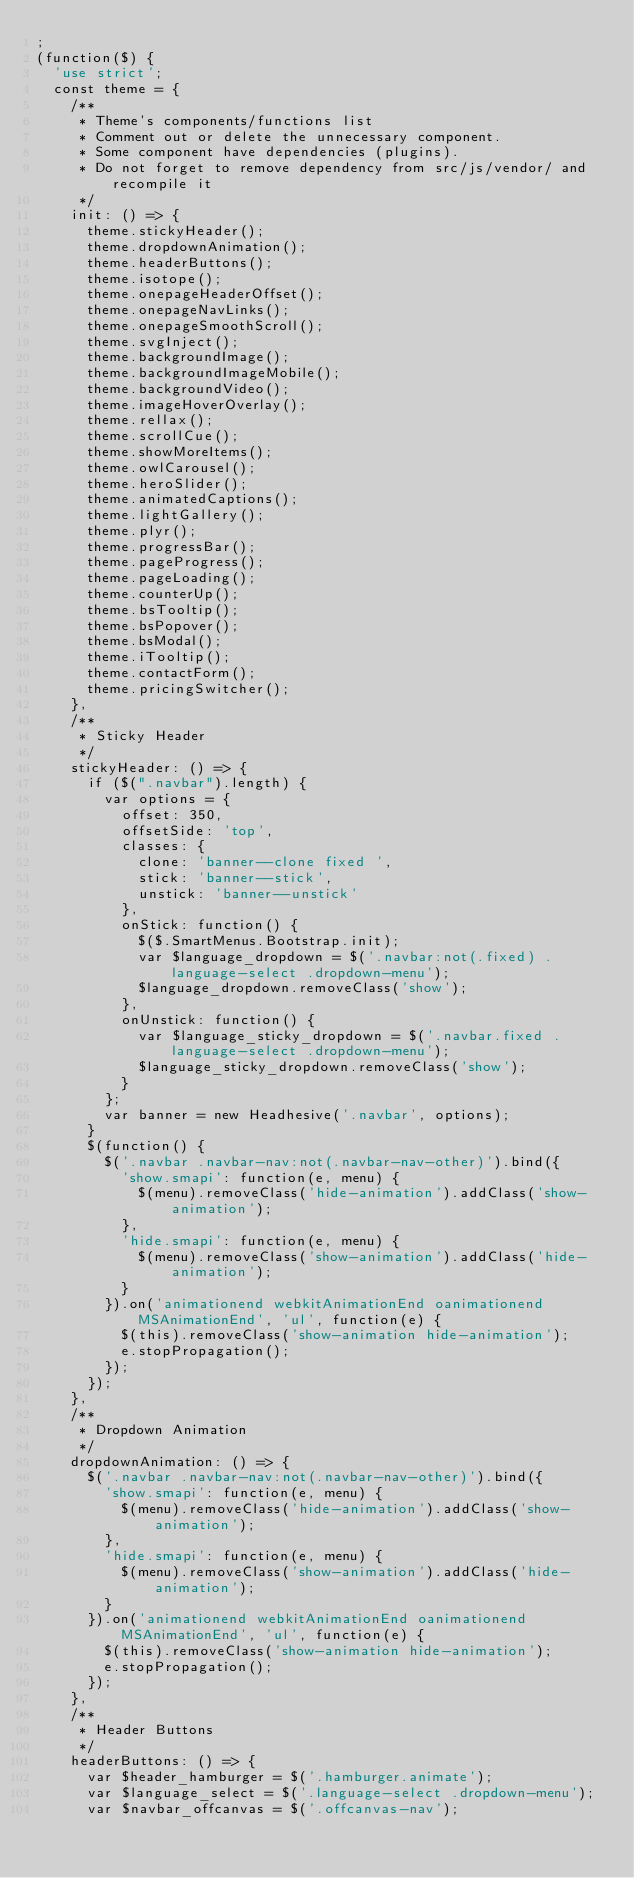<code> <loc_0><loc_0><loc_500><loc_500><_JavaScript_>;
(function($) {
  'use strict';
  const theme = {
    /**
     * Theme's components/functions list
     * Comment out or delete the unnecessary component.
     * Some component have dependencies (plugins).
     * Do not forget to remove dependency from src/js/vendor/ and recompile it
     */
    init: () => {
      theme.stickyHeader();
      theme.dropdownAnimation();
      theme.headerButtons();
      theme.isotope();
      theme.onepageHeaderOffset();
      theme.onepageNavLinks();
      theme.onepageSmoothScroll();
      theme.svgInject();
      theme.backgroundImage();
      theme.backgroundImageMobile();
      theme.backgroundVideo();
      theme.imageHoverOverlay();
      theme.rellax();
      theme.scrollCue();
      theme.showMoreItems();
      theme.owlCarousel();
      theme.heroSlider();
      theme.animatedCaptions();
      theme.lightGallery();
      theme.plyr();
      theme.progressBar();
      theme.pageProgress();
      theme.pageLoading();
      theme.counterUp();
      theme.bsTooltip();
      theme.bsPopover();
      theme.bsModal();
      theme.iTooltip();
      theme.contactForm();
      theme.pricingSwitcher();
    },
    /**
     * Sticky Header
     */
    stickyHeader: () => {
      if ($(".navbar").length) {
        var options = {
          offset: 350,
          offsetSide: 'top',
          classes: {
            clone: 'banner--clone fixed ',
            stick: 'banner--stick',
            unstick: 'banner--unstick'
          },
          onStick: function() {
            $($.SmartMenus.Bootstrap.init);
            var $language_dropdown = $('.navbar:not(.fixed) .language-select .dropdown-menu');
            $language_dropdown.removeClass('show');
          },
          onUnstick: function() {
            var $language_sticky_dropdown = $('.navbar.fixed .language-select .dropdown-menu');
            $language_sticky_dropdown.removeClass('show');
          }
        };
        var banner = new Headhesive('.navbar', options);
      }
      $(function() {
        $('.navbar .navbar-nav:not(.navbar-nav-other)').bind({
          'show.smapi': function(e, menu) {
            $(menu).removeClass('hide-animation').addClass('show-animation');
          },
          'hide.smapi': function(e, menu) {
            $(menu).removeClass('show-animation').addClass('hide-animation');
          }
        }).on('animationend webkitAnimationEnd oanimationend MSAnimationEnd', 'ul', function(e) {
          $(this).removeClass('show-animation hide-animation');
          e.stopPropagation();
        });
      });
    },
    /**
     * Dropdown Animation
     */
    dropdownAnimation: () => {
      $('.navbar .navbar-nav:not(.navbar-nav-other)').bind({
        'show.smapi': function(e, menu) {
          $(menu).removeClass('hide-animation').addClass('show-animation');
        },
        'hide.smapi': function(e, menu) {
          $(menu).removeClass('show-animation').addClass('hide-animation');
        }
      }).on('animationend webkitAnimationEnd oanimationend MSAnimationEnd', 'ul', function(e) {
        $(this).removeClass('show-animation hide-animation');
        e.stopPropagation();
      });
    },
    /**
     * Header Buttons
     */
    headerButtons: () => {
      var $header_hamburger = $('.hamburger.animate');
      var $language_select = $('.language-select .dropdown-menu');
      var $navbar_offcanvas = $('.offcanvas-nav');</code> 